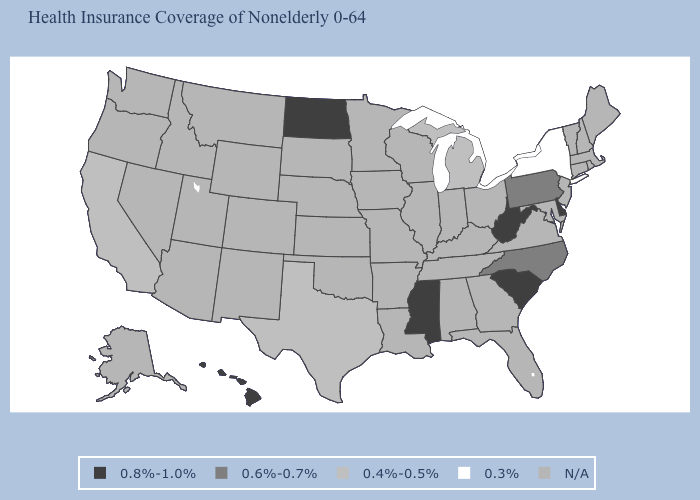Name the states that have a value in the range 0.8%-1.0%?
Quick response, please. Delaware, Hawaii, Mississippi, North Dakota, South Carolina, West Virginia. What is the highest value in the USA?
Quick response, please. 0.8%-1.0%. What is the value of Massachusetts?
Keep it brief. N/A. Name the states that have a value in the range 0.4%-0.5%?
Write a very short answer. California, Michigan, Texas. Name the states that have a value in the range N/A?
Short answer required. Alabama, Alaska, Arizona, Arkansas, Colorado, Connecticut, Florida, Georgia, Idaho, Illinois, Indiana, Iowa, Kansas, Kentucky, Louisiana, Maine, Maryland, Massachusetts, Minnesota, Missouri, Montana, Nebraska, Nevada, New Hampshire, New Jersey, New Mexico, Ohio, Oklahoma, Oregon, Rhode Island, South Dakota, Tennessee, Utah, Vermont, Virginia, Washington, Wisconsin, Wyoming. Name the states that have a value in the range 0.6%-0.7%?
Quick response, please. North Carolina, Pennsylvania. Name the states that have a value in the range 0.8%-1.0%?
Quick response, please. Delaware, Hawaii, Mississippi, North Dakota, South Carolina, West Virginia. Name the states that have a value in the range N/A?
Concise answer only. Alabama, Alaska, Arizona, Arkansas, Colorado, Connecticut, Florida, Georgia, Idaho, Illinois, Indiana, Iowa, Kansas, Kentucky, Louisiana, Maine, Maryland, Massachusetts, Minnesota, Missouri, Montana, Nebraska, Nevada, New Hampshire, New Jersey, New Mexico, Ohio, Oklahoma, Oregon, Rhode Island, South Dakota, Tennessee, Utah, Vermont, Virginia, Washington, Wisconsin, Wyoming. Name the states that have a value in the range N/A?
Give a very brief answer. Alabama, Alaska, Arizona, Arkansas, Colorado, Connecticut, Florida, Georgia, Idaho, Illinois, Indiana, Iowa, Kansas, Kentucky, Louisiana, Maine, Maryland, Massachusetts, Minnesota, Missouri, Montana, Nebraska, Nevada, New Hampshire, New Jersey, New Mexico, Ohio, Oklahoma, Oregon, Rhode Island, South Dakota, Tennessee, Utah, Vermont, Virginia, Washington, Wisconsin, Wyoming. What is the value of Idaho?
Write a very short answer. N/A. Which states have the highest value in the USA?
Answer briefly. Delaware, Hawaii, Mississippi, North Dakota, South Carolina, West Virginia. Name the states that have a value in the range 0.6%-0.7%?
Short answer required. North Carolina, Pennsylvania. Does Michigan have the highest value in the USA?
Concise answer only. No. Is the legend a continuous bar?
Short answer required. No. What is the value of California?
Write a very short answer. 0.4%-0.5%. 